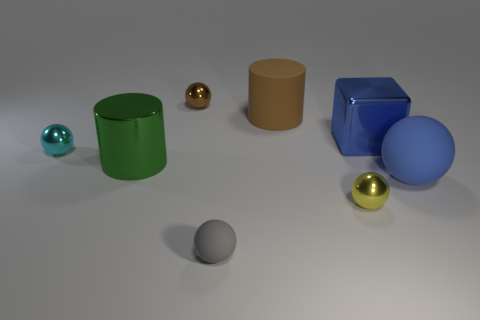Can you describe the different materials that are shown in the image? Certainly! The image shows a variety of objects with different material properties. On the left, there appears to be a shiny translucent green glass cylinder and a smaller teal sphere also made of glass. Just right of center, there's a dull metal sphere and a cardboard-like matte cylinder. On the right, there is a reflective blue plastic cube and a large matte blue sphere, possibly made of a matte painted material. 